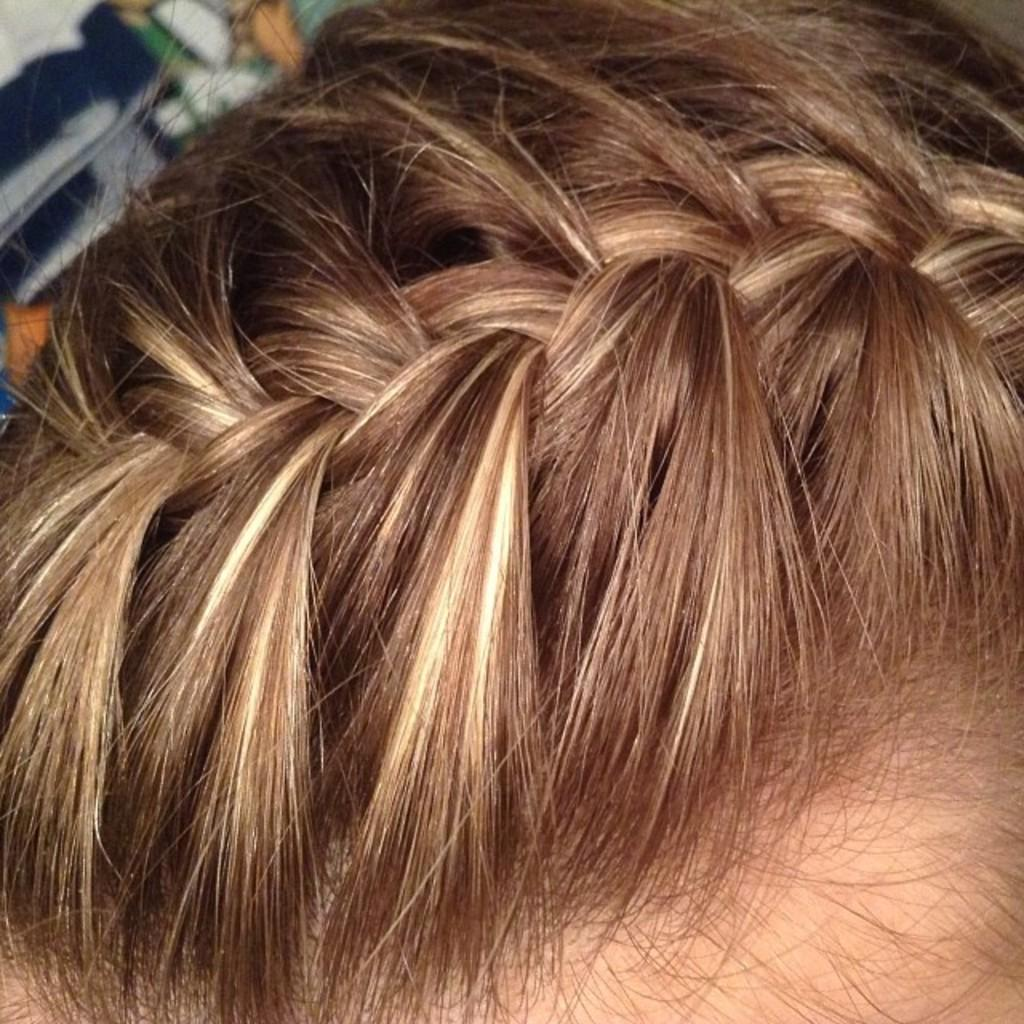What is the main subject of the image? The main subject of the image is a person's head. What can be seen on the person's head? There is hair in the middle of the image. What type of house is depicted in the image? There is no house present in the image; it only contains a person's head and hair. How many nails can be seen in the image? There are no nails present in the image. 